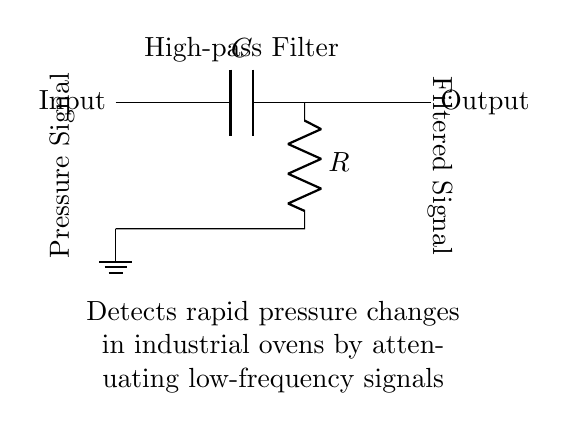What type of filter is shown in the circuit? The circuit is labeled as a "High-pass Filter," which categorizes the filter type based on its ability to allow high-frequency signals to pass while attenuating low-frequency signals.
Answer: High-pass Filter What components are used in this high-pass filter? The circuit diagram includes two primary components: a capacitor (C) and a resistor (R). These components work together to form the filtering function of the circuit.
Answer: Capacitor and Resistor What is the function of the capacitor in this circuit? The capacitor's role in a high-pass filter is to block low-frequency signals while allowing higher-frequency signals to pass through. This characteristic is essential for detecting rapid changes in pressure by ignoring slow variations.
Answer: Blocks low-frequency signals What is being filtered in this circuit? The circuit is specifically designed to filter "Pressure Signal," indicating that it processes inputs related to pressure measurements, focusing on rapid changes rather than steady states.
Answer: Pressure Signal What is the output of the circuit labeled as? The output of the circuit is labeled as "Filtered Signal," which implies that the signal output will be a modified version of the input pressure signal after the filtering effect is applied.
Answer: Filtered Signal How does this filter aid in detecting rapid changes? This high-pass filter detects rapid changes by attenuating lower frequencies that could obscure quick fluctuations in pressure change, thus allowing only significant and fast-changing signals to be recognized and processed.
Answer: Attenuates low-frequency signals What is the significance of grounding in this circuit? Grounding in this circuit provides a reference point for the voltage levels and ensures stability in the circuit operation, allowing accurate measurement of the pressure signal relative to the ground potential.
Answer: Reference point for voltage 